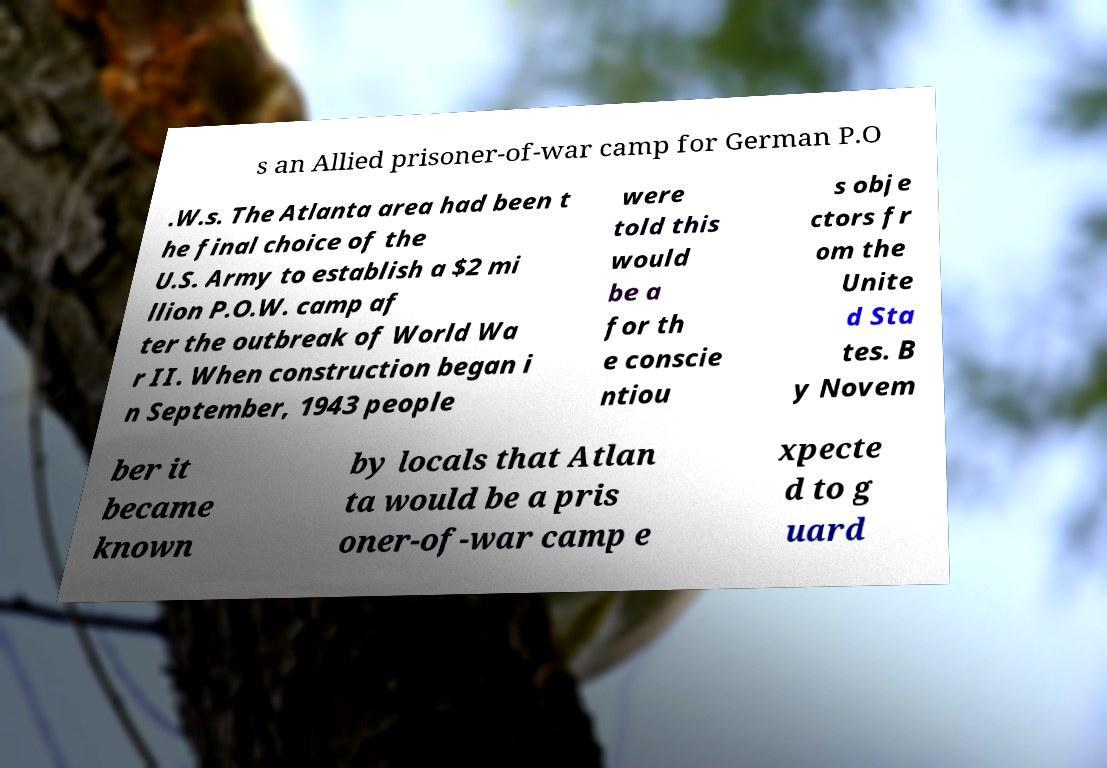There's text embedded in this image that I need extracted. Can you transcribe it verbatim? s an Allied prisoner-of-war camp for German P.O .W.s. The Atlanta area had been t he final choice of the U.S. Army to establish a $2 mi llion P.O.W. camp af ter the outbreak of World Wa r II. When construction began i n September, 1943 people were told this would be a for th e conscie ntiou s obje ctors fr om the Unite d Sta tes. B y Novem ber it became known by locals that Atlan ta would be a pris oner-of-war camp e xpecte d to g uard 